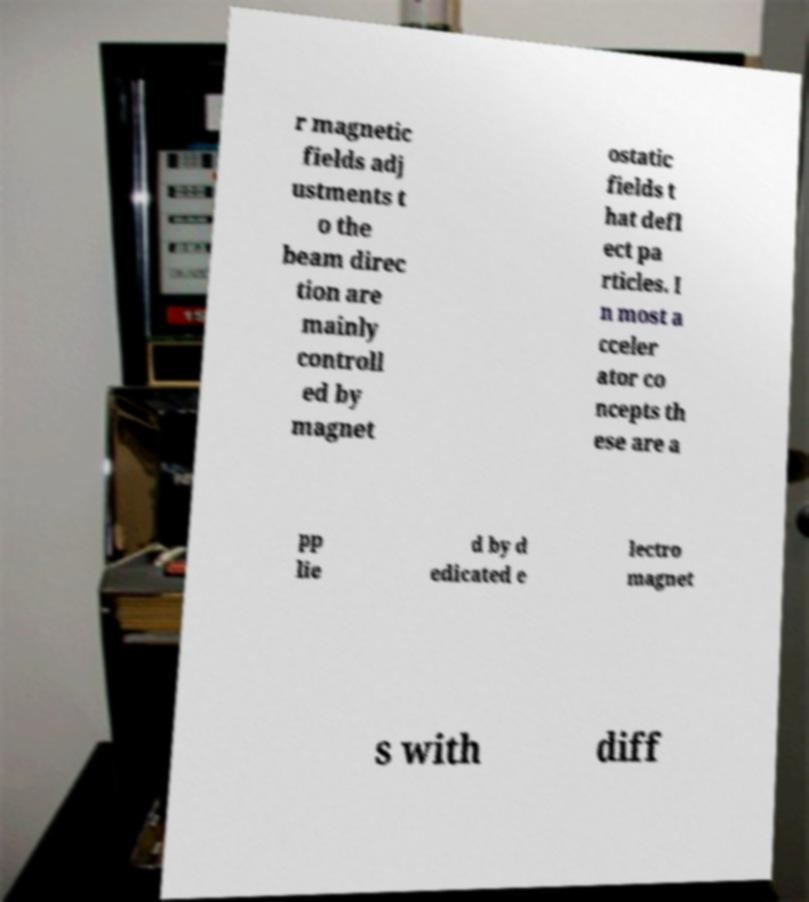Could you assist in decoding the text presented in this image and type it out clearly? r magnetic fields adj ustments t o the beam direc tion are mainly controll ed by magnet ostatic fields t hat defl ect pa rticles. I n most a cceler ator co ncepts th ese are a pp lie d by d edicated e lectro magnet s with diff 